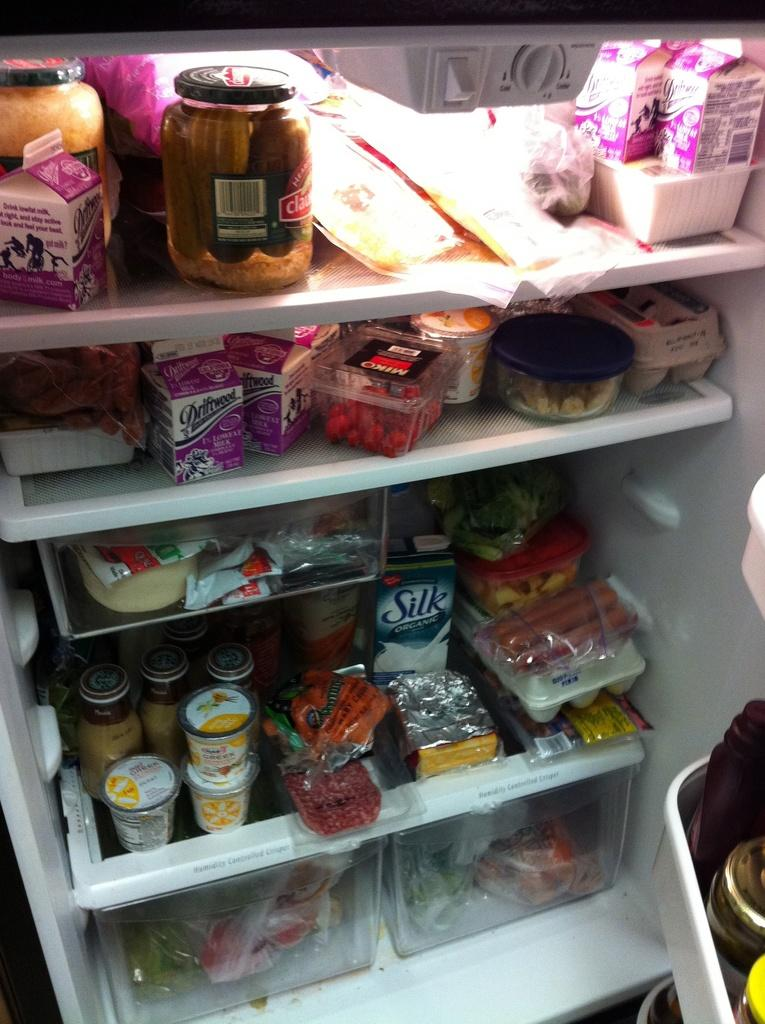Provide a one-sentence caption for the provided image. Refrigerator full of food including an organic Silk soymilk on the bottom. 